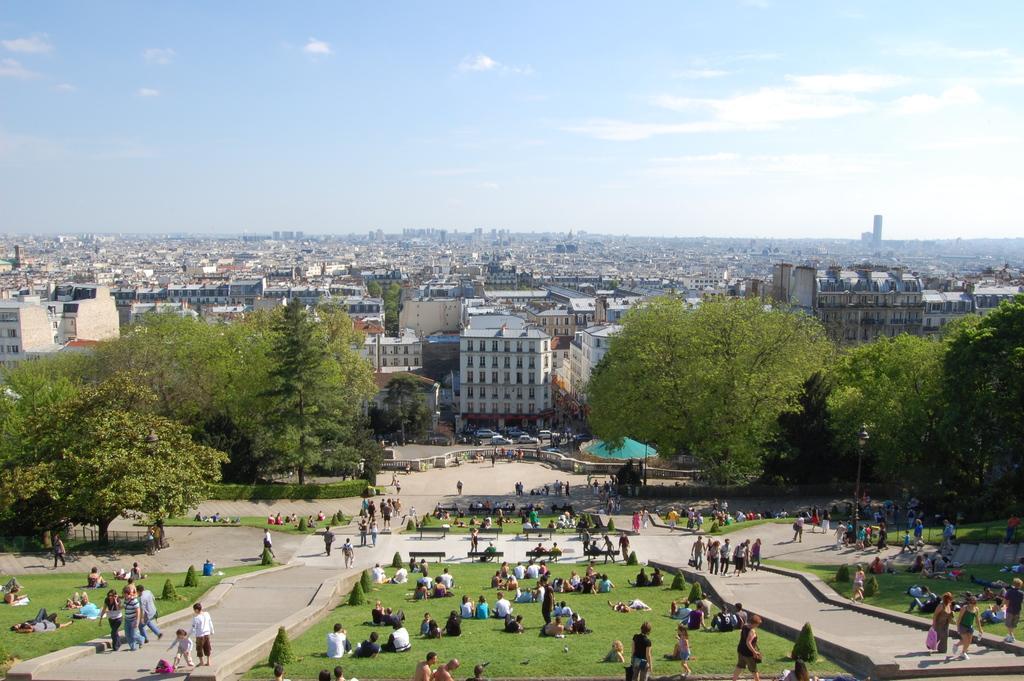Can you describe this image briefly? In this picture I can see some people are walking and some people are sitting on the grass, behind there are some buildings and trees. 